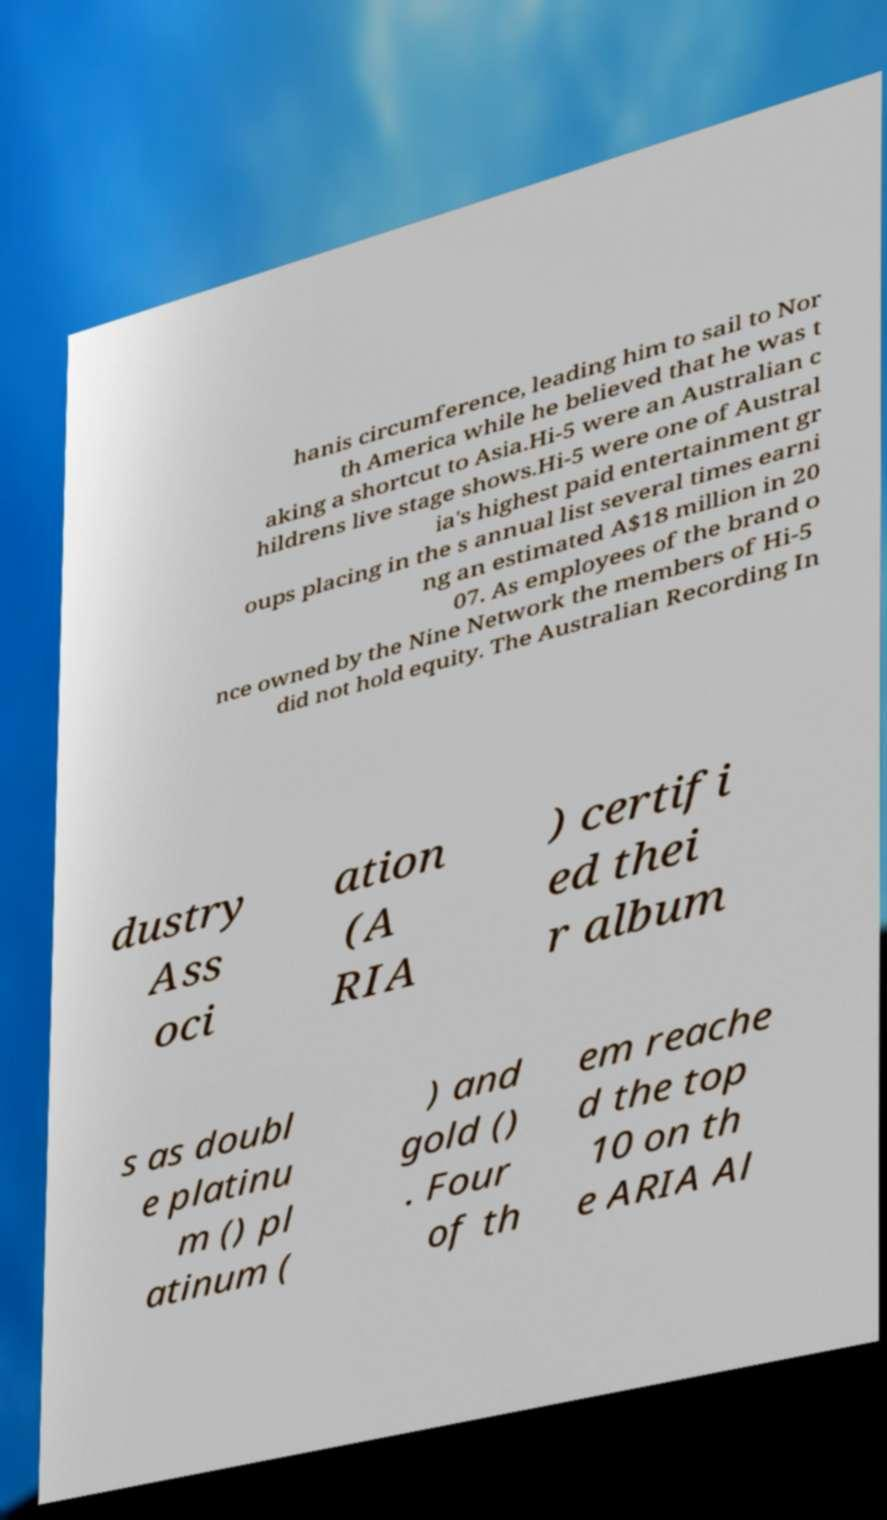For documentation purposes, I need the text within this image transcribed. Could you provide that? hanis circumference, leading him to sail to Nor th America while he believed that he was t aking a shortcut to Asia.Hi-5 were an Australian c hildrens live stage shows.Hi-5 were one of Austral ia's highest paid entertainment gr oups placing in the s annual list several times earni ng an estimated A$18 million in 20 07. As employees of the brand o nce owned by the Nine Network the members of Hi-5 did not hold equity. The Australian Recording In dustry Ass oci ation (A RIA ) certifi ed thei r album s as doubl e platinu m () pl atinum ( ) and gold () . Four of th em reache d the top 10 on th e ARIA Al 